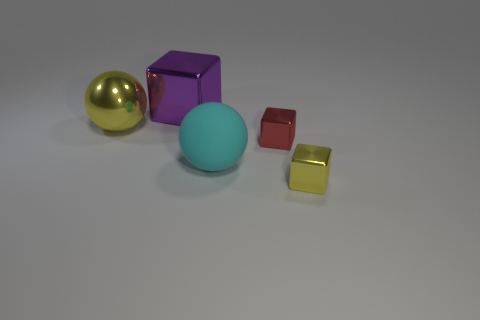What is the material of the tiny thing that is the same color as the large shiny sphere?
Provide a short and direct response. Metal. The other purple thing that is the same size as the matte object is what shape?
Your answer should be compact. Cube. There is a big ball that is in front of the yellow metallic thing behind the cyan object; are there any large purple blocks that are in front of it?
Provide a short and direct response. No. There is a metal ball; is its color the same as the tiny shiny block in front of the matte sphere?
Provide a succinct answer. Yes. How many other large rubber objects are the same color as the big matte object?
Keep it short and to the point. 0. There is a metallic block that is behind the yellow thing that is to the left of the yellow block; how big is it?
Provide a succinct answer. Large. How many objects are either metallic blocks that are right of the big cube or purple blocks?
Make the answer very short. 3. Are there any things that have the same size as the purple block?
Your answer should be very brief. Yes. Are there any cubes that are to the left of the tiny block that is in front of the big cyan rubber sphere?
Your response must be concise. Yes. What number of cubes are either small yellow objects or large purple metallic things?
Your response must be concise. 2. 